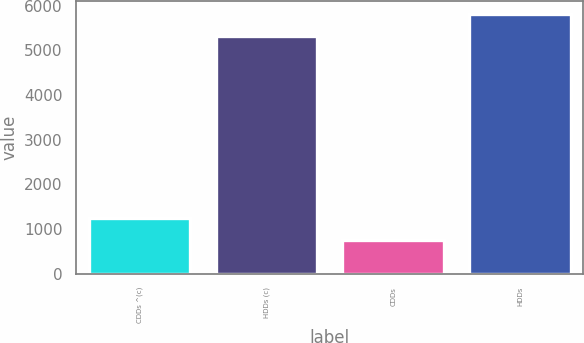Convert chart to OTSL. <chart><loc_0><loc_0><loc_500><loc_500><bar_chart><fcel>CDDs ^(c)<fcel>HDDs (c)<fcel>CDDs<fcel>HDDs<nl><fcel>1252<fcel>5317<fcel>750<fcel>5819<nl></chart> 